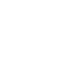Convert code to text. <code><loc_0><loc_0><loc_500><loc_500><_SQL_>  </code> 